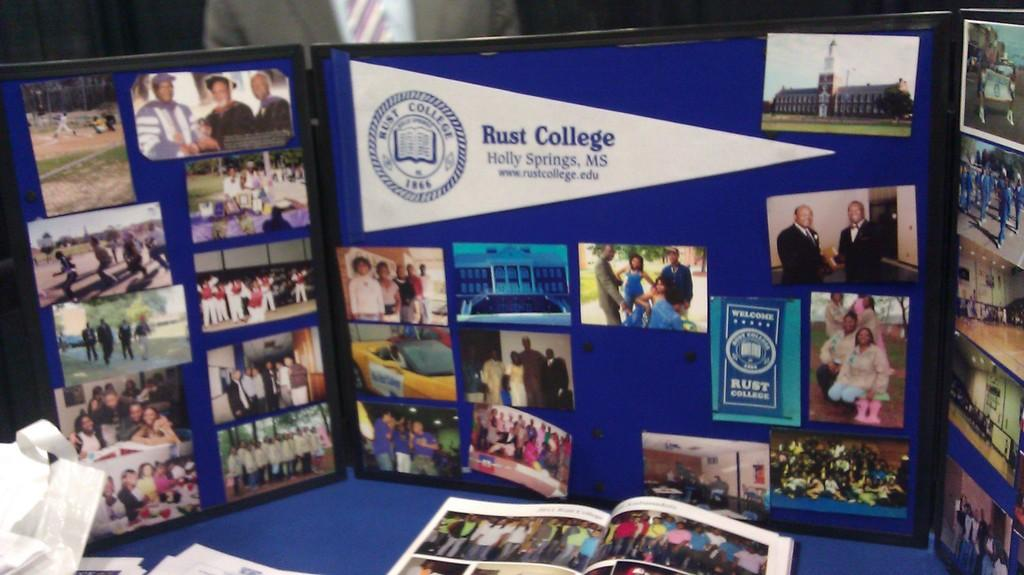<image>
Summarize the visual content of the image. A display board about Rust College is sitting on a table. 